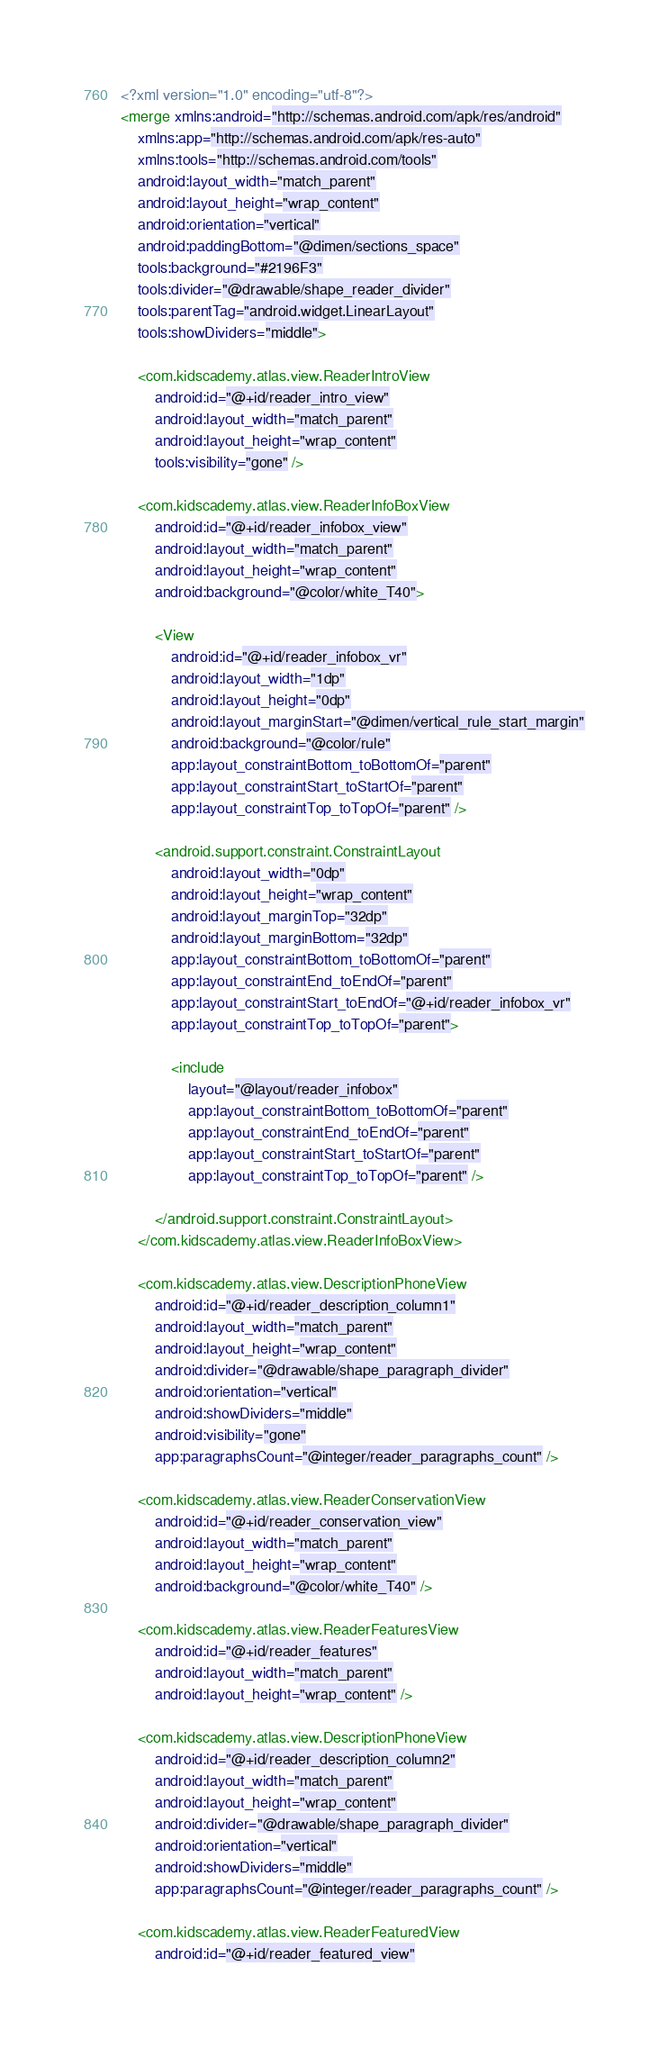<code> <loc_0><loc_0><loc_500><loc_500><_XML_><?xml version="1.0" encoding="utf-8"?>
<merge xmlns:android="http://schemas.android.com/apk/res/android"
    xmlns:app="http://schemas.android.com/apk/res-auto"
    xmlns:tools="http://schemas.android.com/tools"
    android:layout_width="match_parent"
    android:layout_height="wrap_content"
    android:orientation="vertical"
    android:paddingBottom="@dimen/sections_space"
    tools:background="#2196F3"
    tools:divider="@drawable/shape_reader_divider"
    tools:parentTag="android.widget.LinearLayout"
    tools:showDividers="middle">

    <com.kidscademy.atlas.view.ReaderIntroView
        android:id="@+id/reader_intro_view"
        android:layout_width="match_parent"
        android:layout_height="wrap_content"
        tools:visibility="gone" />

    <com.kidscademy.atlas.view.ReaderInfoBoxView
        android:id="@+id/reader_infobox_view"
        android:layout_width="match_parent"
        android:layout_height="wrap_content"
        android:background="@color/white_T40">

        <View
            android:id="@+id/reader_infobox_vr"
            android:layout_width="1dp"
            android:layout_height="0dp"
            android:layout_marginStart="@dimen/vertical_rule_start_margin"
            android:background="@color/rule"
            app:layout_constraintBottom_toBottomOf="parent"
            app:layout_constraintStart_toStartOf="parent"
            app:layout_constraintTop_toTopOf="parent" />

        <android.support.constraint.ConstraintLayout
            android:layout_width="0dp"
            android:layout_height="wrap_content"
            android:layout_marginTop="32dp"
            android:layout_marginBottom="32dp"
            app:layout_constraintBottom_toBottomOf="parent"
            app:layout_constraintEnd_toEndOf="parent"
            app:layout_constraintStart_toEndOf="@+id/reader_infobox_vr"
            app:layout_constraintTop_toTopOf="parent">

            <include
                layout="@layout/reader_infobox"
                app:layout_constraintBottom_toBottomOf="parent"
                app:layout_constraintEnd_toEndOf="parent"
                app:layout_constraintStart_toStartOf="parent"
                app:layout_constraintTop_toTopOf="parent" />

        </android.support.constraint.ConstraintLayout>
    </com.kidscademy.atlas.view.ReaderInfoBoxView>

    <com.kidscademy.atlas.view.DescriptionPhoneView
        android:id="@+id/reader_description_column1"
        android:layout_width="match_parent"
        android:layout_height="wrap_content"
        android:divider="@drawable/shape_paragraph_divider"
        android:orientation="vertical"
        android:showDividers="middle"
        android:visibility="gone"
        app:paragraphsCount="@integer/reader_paragraphs_count" />

    <com.kidscademy.atlas.view.ReaderConservationView
        android:id="@+id/reader_conservation_view"
        android:layout_width="match_parent"
        android:layout_height="wrap_content"
        android:background="@color/white_T40" />

    <com.kidscademy.atlas.view.ReaderFeaturesView
        android:id="@+id/reader_features"
        android:layout_width="match_parent"
        android:layout_height="wrap_content" />

    <com.kidscademy.atlas.view.DescriptionPhoneView
        android:id="@+id/reader_description_column2"
        android:layout_width="match_parent"
        android:layout_height="wrap_content"
        android:divider="@drawable/shape_paragraph_divider"
        android:orientation="vertical"
        android:showDividers="middle"
        app:paragraphsCount="@integer/reader_paragraphs_count" />

    <com.kidscademy.atlas.view.ReaderFeaturedView
        android:id="@+id/reader_featured_view"</code> 